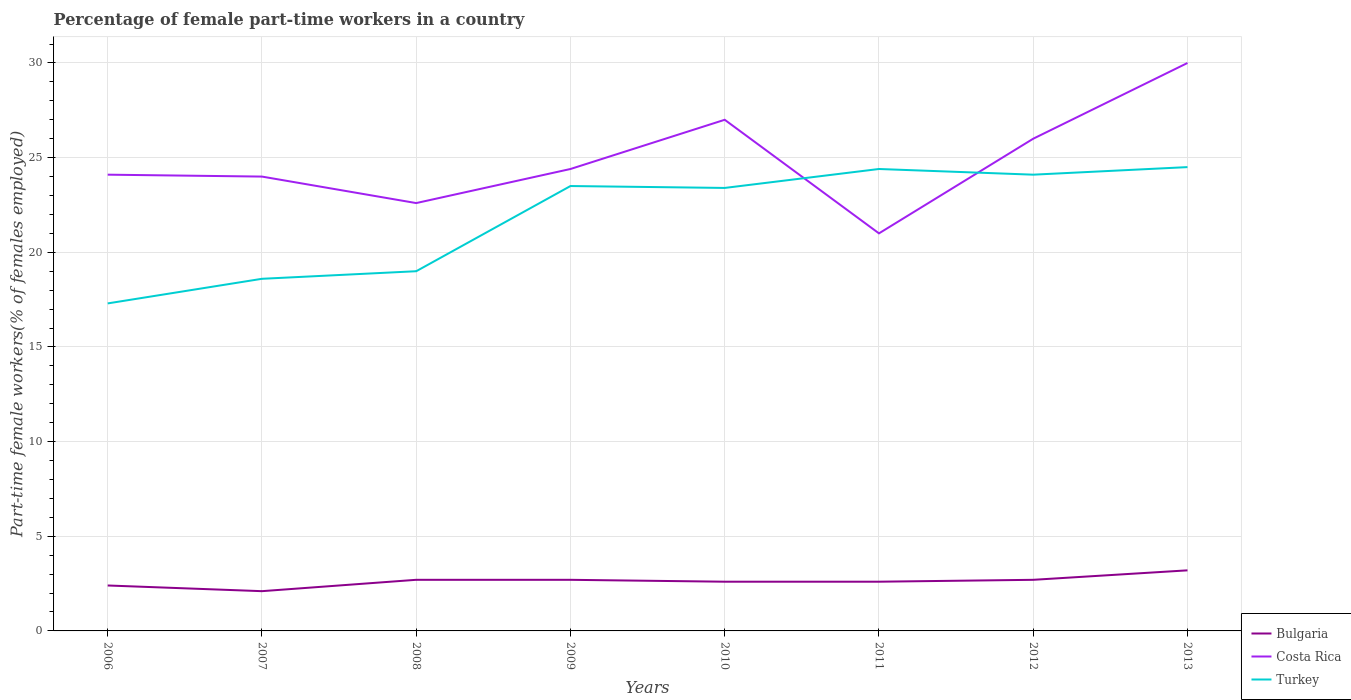Does the line corresponding to Costa Rica intersect with the line corresponding to Bulgaria?
Provide a short and direct response. No. Is the number of lines equal to the number of legend labels?
Ensure brevity in your answer.  Yes. Across all years, what is the maximum percentage of female part-time workers in Costa Rica?
Offer a terse response. 21. What is the total percentage of female part-time workers in Costa Rica in the graph?
Your answer should be very brief. -1.8. What is the difference between the highest and the second highest percentage of female part-time workers in Turkey?
Your answer should be compact. 7.2. What is the difference between the highest and the lowest percentage of female part-time workers in Turkey?
Your answer should be very brief. 5. Are the values on the major ticks of Y-axis written in scientific E-notation?
Make the answer very short. No. Does the graph contain grids?
Provide a short and direct response. Yes. Where does the legend appear in the graph?
Your answer should be very brief. Bottom right. How are the legend labels stacked?
Your answer should be very brief. Vertical. What is the title of the graph?
Ensure brevity in your answer.  Percentage of female part-time workers in a country. Does "Liberia" appear as one of the legend labels in the graph?
Your answer should be compact. No. What is the label or title of the X-axis?
Your answer should be very brief. Years. What is the label or title of the Y-axis?
Ensure brevity in your answer.  Part-time female workers(% of females employed). What is the Part-time female workers(% of females employed) of Bulgaria in 2006?
Keep it short and to the point. 2.4. What is the Part-time female workers(% of females employed) of Costa Rica in 2006?
Your response must be concise. 24.1. What is the Part-time female workers(% of females employed) in Turkey in 2006?
Provide a succinct answer. 17.3. What is the Part-time female workers(% of females employed) of Bulgaria in 2007?
Provide a short and direct response. 2.1. What is the Part-time female workers(% of females employed) in Costa Rica in 2007?
Your answer should be compact. 24. What is the Part-time female workers(% of females employed) in Turkey in 2007?
Give a very brief answer. 18.6. What is the Part-time female workers(% of females employed) of Bulgaria in 2008?
Your answer should be compact. 2.7. What is the Part-time female workers(% of females employed) in Costa Rica in 2008?
Ensure brevity in your answer.  22.6. What is the Part-time female workers(% of females employed) of Bulgaria in 2009?
Provide a short and direct response. 2.7. What is the Part-time female workers(% of females employed) of Costa Rica in 2009?
Make the answer very short. 24.4. What is the Part-time female workers(% of females employed) of Bulgaria in 2010?
Your answer should be compact. 2.6. What is the Part-time female workers(% of females employed) in Turkey in 2010?
Ensure brevity in your answer.  23.4. What is the Part-time female workers(% of females employed) of Bulgaria in 2011?
Provide a succinct answer. 2.6. What is the Part-time female workers(% of females employed) of Costa Rica in 2011?
Provide a short and direct response. 21. What is the Part-time female workers(% of females employed) of Turkey in 2011?
Keep it short and to the point. 24.4. What is the Part-time female workers(% of females employed) of Bulgaria in 2012?
Provide a short and direct response. 2.7. What is the Part-time female workers(% of females employed) of Costa Rica in 2012?
Provide a succinct answer. 26. What is the Part-time female workers(% of females employed) of Turkey in 2012?
Make the answer very short. 24.1. What is the Part-time female workers(% of females employed) in Bulgaria in 2013?
Keep it short and to the point. 3.2. What is the Part-time female workers(% of females employed) in Costa Rica in 2013?
Make the answer very short. 30. What is the Part-time female workers(% of females employed) of Turkey in 2013?
Ensure brevity in your answer.  24.5. Across all years, what is the maximum Part-time female workers(% of females employed) in Bulgaria?
Your answer should be very brief. 3.2. Across all years, what is the minimum Part-time female workers(% of females employed) in Bulgaria?
Give a very brief answer. 2.1. Across all years, what is the minimum Part-time female workers(% of females employed) in Costa Rica?
Offer a very short reply. 21. Across all years, what is the minimum Part-time female workers(% of females employed) of Turkey?
Your answer should be compact. 17.3. What is the total Part-time female workers(% of females employed) of Costa Rica in the graph?
Offer a very short reply. 199.1. What is the total Part-time female workers(% of females employed) in Turkey in the graph?
Provide a succinct answer. 174.8. What is the difference between the Part-time female workers(% of females employed) of Bulgaria in 2006 and that in 2007?
Make the answer very short. 0.3. What is the difference between the Part-time female workers(% of females employed) in Bulgaria in 2006 and that in 2008?
Offer a terse response. -0.3. What is the difference between the Part-time female workers(% of females employed) of Costa Rica in 2006 and that in 2008?
Offer a very short reply. 1.5. What is the difference between the Part-time female workers(% of females employed) in Turkey in 2006 and that in 2008?
Make the answer very short. -1.7. What is the difference between the Part-time female workers(% of females employed) in Bulgaria in 2006 and that in 2009?
Keep it short and to the point. -0.3. What is the difference between the Part-time female workers(% of females employed) of Costa Rica in 2006 and that in 2009?
Make the answer very short. -0.3. What is the difference between the Part-time female workers(% of females employed) in Bulgaria in 2006 and that in 2010?
Ensure brevity in your answer.  -0.2. What is the difference between the Part-time female workers(% of females employed) in Turkey in 2006 and that in 2010?
Offer a very short reply. -6.1. What is the difference between the Part-time female workers(% of females employed) of Costa Rica in 2006 and that in 2011?
Your response must be concise. 3.1. What is the difference between the Part-time female workers(% of females employed) of Turkey in 2006 and that in 2011?
Give a very brief answer. -7.1. What is the difference between the Part-time female workers(% of females employed) in Costa Rica in 2006 and that in 2013?
Offer a very short reply. -5.9. What is the difference between the Part-time female workers(% of females employed) of Bulgaria in 2007 and that in 2008?
Give a very brief answer. -0.6. What is the difference between the Part-time female workers(% of females employed) of Bulgaria in 2007 and that in 2010?
Your response must be concise. -0.5. What is the difference between the Part-time female workers(% of females employed) of Bulgaria in 2007 and that in 2011?
Ensure brevity in your answer.  -0.5. What is the difference between the Part-time female workers(% of females employed) of Bulgaria in 2007 and that in 2012?
Offer a terse response. -0.6. What is the difference between the Part-time female workers(% of females employed) in Costa Rica in 2007 and that in 2012?
Provide a short and direct response. -2. What is the difference between the Part-time female workers(% of females employed) in Costa Rica in 2007 and that in 2013?
Ensure brevity in your answer.  -6. What is the difference between the Part-time female workers(% of females employed) in Turkey in 2007 and that in 2013?
Ensure brevity in your answer.  -5.9. What is the difference between the Part-time female workers(% of females employed) of Costa Rica in 2008 and that in 2010?
Make the answer very short. -4.4. What is the difference between the Part-time female workers(% of females employed) in Turkey in 2008 and that in 2010?
Keep it short and to the point. -4.4. What is the difference between the Part-time female workers(% of females employed) of Bulgaria in 2008 and that in 2011?
Your response must be concise. 0.1. What is the difference between the Part-time female workers(% of females employed) of Costa Rica in 2008 and that in 2012?
Your answer should be very brief. -3.4. What is the difference between the Part-time female workers(% of females employed) in Bulgaria in 2008 and that in 2013?
Keep it short and to the point. -0.5. What is the difference between the Part-time female workers(% of females employed) in Costa Rica in 2008 and that in 2013?
Offer a very short reply. -7.4. What is the difference between the Part-time female workers(% of females employed) in Bulgaria in 2009 and that in 2010?
Ensure brevity in your answer.  0.1. What is the difference between the Part-time female workers(% of females employed) of Turkey in 2009 and that in 2010?
Offer a terse response. 0.1. What is the difference between the Part-time female workers(% of females employed) in Bulgaria in 2009 and that in 2011?
Ensure brevity in your answer.  0.1. What is the difference between the Part-time female workers(% of females employed) of Costa Rica in 2009 and that in 2012?
Ensure brevity in your answer.  -1.6. What is the difference between the Part-time female workers(% of females employed) of Bulgaria in 2009 and that in 2013?
Keep it short and to the point. -0.5. What is the difference between the Part-time female workers(% of females employed) in Costa Rica in 2009 and that in 2013?
Offer a very short reply. -5.6. What is the difference between the Part-time female workers(% of females employed) of Bulgaria in 2010 and that in 2011?
Make the answer very short. 0. What is the difference between the Part-time female workers(% of females employed) in Turkey in 2010 and that in 2011?
Your answer should be very brief. -1. What is the difference between the Part-time female workers(% of females employed) of Costa Rica in 2010 and that in 2012?
Offer a very short reply. 1. What is the difference between the Part-time female workers(% of females employed) of Turkey in 2010 and that in 2012?
Your response must be concise. -0.7. What is the difference between the Part-time female workers(% of females employed) in Bulgaria in 2010 and that in 2013?
Your answer should be very brief. -0.6. What is the difference between the Part-time female workers(% of females employed) in Costa Rica in 2010 and that in 2013?
Provide a succinct answer. -3. What is the difference between the Part-time female workers(% of females employed) in Bulgaria in 2011 and that in 2012?
Your response must be concise. -0.1. What is the difference between the Part-time female workers(% of females employed) of Costa Rica in 2011 and that in 2012?
Provide a succinct answer. -5. What is the difference between the Part-time female workers(% of females employed) in Turkey in 2011 and that in 2012?
Provide a short and direct response. 0.3. What is the difference between the Part-time female workers(% of females employed) in Bulgaria in 2011 and that in 2013?
Offer a very short reply. -0.6. What is the difference between the Part-time female workers(% of females employed) in Costa Rica in 2012 and that in 2013?
Your answer should be very brief. -4. What is the difference between the Part-time female workers(% of females employed) of Bulgaria in 2006 and the Part-time female workers(% of females employed) of Costa Rica in 2007?
Provide a succinct answer. -21.6. What is the difference between the Part-time female workers(% of females employed) of Bulgaria in 2006 and the Part-time female workers(% of females employed) of Turkey in 2007?
Ensure brevity in your answer.  -16.2. What is the difference between the Part-time female workers(% of females employed) of Costa Rica in 2006 and the Part-time female workers(% of females employed) of Turkey in 2007?
Offer a very short reply. 5.5. What is the difference between the Part-time female workers(% of females employed) in Bulgaria in 2006 and the Part-time female workers(% of females employed) in Costa Rica in 2008?
Keep it short and to the point. -20.2. What is the difference between the Part-time female workers(% of females employed) in Bulgaria in 2006 and the Part-time female workers(% of females employed) in Turkey in 2008?
Offer a very short reply. -16.6. What is the difference between the Part-time female workers(% of females employed) in Costa Rica in 2006 and the Part-time female workers(% of females employed) in Turkey in 2008?
Make the answer very short. 5.1. What is the difference between the Part-time female workers(% of females employed) of Bulgaria in 2006 and the Part-time female workers(% of females employed) of Turkey in 2009?
Your response must be concise. -21.1. What is the difference between the Part-time female workers(% of females employed) in Costa Rica in 2006 and the Part-time female workers(% of females employed) in Turkey in 2009?
Provide a succinct answer. 0.6. What is the difference between the Part-time female workers(% of females employed) of Bulgaria in 2006 and the Part-time female workers(% of females employed) of Costa Rica in 2010?
Offer a very short reply. -24.6. What is the difference between the Part-time female workers(% of females employed) of Bulgaria in 2006 and the Part-time female workers(% of females employed) of Turkey in 2010?
Keep it short and to the point. -21. What is the difference between the Part-time female workers(% of females employed) in Costa Rica in 2006 and the Part-time female workers(% of females employed) in Turkey in 2010?
Make the answer very short. 0.7. What is the difference between the Part-time female workers(% of females employed) in Bulgaria in 2006 and the Part-time female workers(% of females employed) in Costa Rica in 2011?
Provide a short and direct response. -18.6. What is the difference between the Part-time female workers(% of females employed) in Bulgaria in 2006 and the Part-time female workers(% of females employed) in Turkey in 2011?
Provide a succinct answer. -22. What is the difference between the Part-time female workers(% of females employed) in Costa Rica in 2006 and the Part-time female workers(% of females employed) in Turkey in 2011?
Provide a succinct answer. -0.3. What is the difference between the Part-time female workers(% of females employed) in Bulgaria in 2006 and the Part-time female workers(% of females employed) in Costa Rica in 2012?
Your response must be concise. -23.6. What is the difference between the Part-time female workers(% of females employed) in Bulgaria in 2006 and the Part-time female workers(% of females employed) in Turkey in 2012?
Your response must be concise. -21.7. What is the difference between the Part-time female workers(% of females employed) of Costa Rica in 2006 and the Part-time female workers(% of females employed) of Turkey in 2012?
Make the answer very short. 0. What is the difference between the Part-time female workers(% of females employed) of Bulgaria in 2006 and the Part-time female workers(% of females employed) of Costa Rica in 2013?
Provide a succinct answer. -27.6. What is the difference between the Part-time female workers(% of females employed) in Bulgaria in 2006 and the Part-time female workers(% of females employed) in Turkey in 2013?
Provide a short and direct response. -22.1. What is the difference between the Part-time female workers(% of females employed) of Bulgaria in 2007 and the Part-time female workers(% of females employed) of Costa Rica in 2008?
Offer a very short reply. -20.5. What is the difference between the Part-time female workers(% of females employed) in Bulgaria in 2007 and the Part-time female workers(% of females employed) in Turkey in 2008?
Your answer should be very brief. -16.9. What is the difference between the Part-time female workers(% of females employed) in Costa Rica in 2007 and the Part-time female workers(% of females employed) in Turkey in 2008?
Provide a succinct answer. 5. What is the difference between the Part-time female workers(% of females employed) in Bulgaria in 2007 and the Part-time female workers(% of females employed) in Costa Rica in 2009?
Provide a succinct answer. -22.3. What is the difference between the Part-time female workers(% of females employed) of Bulgaria in 2007 and the Part-time female workers(% of females employed) of Turkey in 2009?
Provide a succinct answer. -21.4. What is the difference between the Part-time female workers(% of females employed) of Costa Rica in 2007 and the Part-time female workers(% of females employed) of Turkey in 2009?
Give a very brief answer. 0.5. What is the difference between the Part-time female workers(% of females employed) of Bulgaria in 2007 and the Part-time female workers(% of females employed) of Costa Rica in 2010?
Offer a terse response. -24.9. What is the difference between the Part-time female workers(% of females employed) in Bulgaria in 2007 and the Part-time female workers(% of females employed) in Turkey in 2010?
Provide a succinct answer. -21.3. What is the difference between the Part-time female workers(% of females employed) in Bulgaria in 2007 and the Part-time female workers(% of females employed) in Costa Rica in 2011?
Your answer should be very brief. -18.9. What is the difference between the Part-time female workers(% of females employed) of Bulgaria in 2007 and the Part-time female workers(% of females employed) of Turkey in 2011?
Give a very brief answer. -22.3. What is the difference between the Part-time female workers(% of females employed) in Costa Rica in 2007 and the Part-time female workers(% of females employed) in Turkey in 2011?
Keep it short and to the point. -0.4. What is the difference between the Part-time female workers(% of females employed) in Bulgaria in 2007 and the Part-time female workers(% of females employed) in Costa Rica in 2012?
Your response must be concise. -23.9. What is the difference between the Part-time female workers(% of females employed) of Bulgaria in 2007 and the Part-time female workers(% of females employed) of Turkey in 2012?
Provide a succinct answer. -22. What is the difference between the Part-time female workers(% of females employed) of Costa Rica in 2007 and the Part-time female workers(% of females employed) of Turkey in 2012?
Keep it short and to the point. -0.1. What is the difference between the Part-time female workers(% of females employed) in Bulgaria in 2007 and the Part-time female workers(% of females employed) in Costa Rica in 2013?
Your response must be concise. -27.9. What is the difference between the Part-time female workers(% of females employed) in Bulgaria in 2007 and the Part-time female workers(% of females employed) in Turkey in 2013?
Keep it short and to the point. -22.4. What is the difference between the Part-time female workers(% of females employed) in Costa Rica in 2007 and the Part-time female workers(% of females employed) in Turkey in 2013?
Make the answer very short. -0.5. What is the difference between the Part-time female workers(% of females employed) of Bulgaria in 2008 and the Part-time female workers(% of females employed) of Costa Rica in 2009?
Offer a very short reply. -21.7. What is the difference between the Part-time female workers(% of females employed) in Bulgaria in 2008 and the Part-time female workers(% of females employed) in Turkey in 2009?
Provide a succinct answer. -20.8. What is the difference between the Part-time female workers(% of females employed) in Bulgaria in 2008 and the Part-time female workers(% of females employed) in Costa Rica in 2010?
Offer a very short reply. -24.3. What is the difference between the Part-time female workers(% of females employed) of Bulgaria in 2008 and the Part-time female workers(% of females employed) of Turkey in 2010?
Ensure brevity in your answer.  -20.7. What is the difference between the Part-time female workers(% of females employed) in Bulgaria in 2008 and the Part-time female workers(% of females employed) in Costa Rica in 2011?
Your response must be concise. -18.3. What is the difference between the Part-time female workers(% of females employed) in Bulgaria in 2008 and the Part-time female workers(% of females employed) in Turkey in 2011?
Provide a succinct answer. -21.7. What is the difference between the Part-time female workers(% of females employed) of Bulgaria in 2008 and the Part-time female workers(% of females employed) of Costa Rica in 2012?
Give a very brief answer. -23.3. What is the difference between the Part-time female workers(% of females employed) of Bulgaria in 2008 and the Part-time female workers(% of females employed) of Turkey in 2012?
Give a very brief answer. -21.4. What is the difference between the Part-time female workers(% of females employed) of Costa Rica in 2008 and the Part-time female workers(% of females employed) of Turkey in 2012?
Give a very brief answer. -1.5. What is the difference between the Part-time female workers(% of females employed) of Bulgaria in 2008 and the Part-time female workers(% of females employed) of Costa Rica in 2013?
Offer a very short reply. -27.3. What is the difference between the Part-time female workers(% of females employed) of Bulgaria in 2008 and the Part-time female workers(% of females employed) of Turkey in 2013?
Offer a terse response. -21.8. What is the difference between the Part-time female workers(% of females employed) in Costa Rica in 2008 and the Part-time female workers(% of females employed) in Turkey in 2013?
Make the answer very short. -1.9. What is the difference between the Part-time female workers(% of females employed) of Bulgaria in 2009 and the Part-time female workers(% of females employed) of Costa Rica in 2010?
Provide a short and direct response. -24.3. What is the difference between the Part-time female workers(% of females employed) of Bulgaria in 2009 and the Part-time female workers(% of females employed) of Turkey in 2010?
Offer a terse response. -20.7. What is the difference between the Part-time female workers(% of females employed) in Bulgaria in 2009 and the Part-time female workers(% of females employed) in Costa Rica in 2011?
Ensure brevity in your answer.  -18.3. What is the difference between the Part-time female workers(% of females employed) of Bulgaria in 2009 and the Part-time female workers(% of females employed) of Turkey in 2011?
Give a very brief answer. -21.7. What is the difference between the Part-time female workers(% of females employed) of Costa Rica in 2009 and the Part-time female workers(% of females employed) of Turkey in 2011?
Your answer should be very brief. 0. What is the difference between the Part-time female workers(% of females employed) of Bulgaria in 2009 and the Part-time female workers(% of females employed) of Costa Rica in 2012?
Your answer should be very brief. -23.3. What is the difference between the Part-time female workers(% of females employed) of Bulgaria in 2009 and the Part-time female workers(% of females employed) of Turkey in 2012?
Ensure brevity in your answer.  -21.4. What is the difference between the Part-time female workers(% of females employed) of Bulgaria in 2009 and the Part-time female workers(% of females employed) of Costa Rica in 2013?
Ensure brevity in your answer.  -27.3. What is the difference between the Part-time female workers(% of females employed) of Bulgaria in 2009 and the Part-time female workers(% of females employed) of Turkey in 2013?
Your answer should be very brief. -21.8. What is the difference between the Part-time female workers(% of females employed) of Costa Rica in 2009 and the Part-time female workers(% of females employed) of Turkey in 2013?
Keep it short and to the point. -0.1. What is the difference between the Part-time female workers(% of females employed) in Bulgaria in 2010 and the Part-time female workers(% of females employed) in Costa Rica in 2011?
Offer a very short reply. -18.4. What is the difference between the Part-time female workers(% of females employed) in Bulgaria in 2010 and the Part-time female workers(% of females employed) in Turkey in 2011?
Your answer should be compact. -21.8. What is the difference between the Part-time female workers(% of females employed) in Bulgaria in 2010 and the Part-time female workers(% of females employed) in Costa Rica in 2012?
Keep it short and to the point. -23.4. What is the difference between the Part-time female workers(% of females employed) of Bulgaria in 2010 and the Part-time female workers(% of females employed) of Turkey in 2012?
Ensure brevity in your answer.  -21.5. What is the difference between the Part-time female workers(% of females employed) of Costa Rica in 2010 and the Part-time female workers(% of females employed) of Turkey in 2012?
Offer a very short reply. 2.9. What is the difference between the Part-time female workers(% of females employed) in Bulgaria in 2010 and the Part-time female workers(% of females employed) in Costa Rica in 2013?
Your answer should be compact. -27.4. What is the difference between the Part-time female workers(% of females employed) in Bulgaria in 2010 and the Part-time female workers(% of females employed) in Turkey in 2013?
Your answer should be very brief. -21.9. What is the difference between the Part-time female workers(% of females employed) in Bulgaria in 2011 and the Part-time female workers(% of females employed) in Costa Rica in 2012?
Offer a terse response. -23.4. What is the difference between the Part-time female workers(% of females employed) of Bulgaria in 2011 and the Part-time female workers(% of females employed) of Turkey in 2012?
Your response must be concise. -21.5. What is the difference between the Part-time female workers(% of females employed) of Bulgaria in 2011 and the Part-time female workers(% of females employed) of Costa Rica in 2013?
Keep it short and to the point. -27.4. What is the difference between the Part-time female workers(% of females employed) of Bulgaria in 2011 and the Part-time female workers(% of females employed) of Turkey in 2013?
Offer a terse response. -21.9. What is the difference between the Part-time female workers(% of females employed) in Costa Rica in 2011 and the Part-time female workers(% of females employed) in Turkey in 2013?
Make the answer very short. -3.5. What is the difference between the Part-time female workers(% of females employed) of Bulgaria in 2012 and the Part-time female workers(% of females employed) of Costa Rica in 2013?
Provide a succinct answer. -27.3. What is the difference between the Part-time female workers(% of females employed) of Bulgaria in 2012 and the Part-time female workers(% of females employed) of Turkey in 2013?
Your response must be concise. -21.8. What is the average Part-time female workers(% of females employed) of Bulgaria per year?
Keep it short and to the point. 2.62. What is the average Part-time female workers(% of females employed) in Costa Rica per year?
Your response must be concise. 24.89. What is the average Part-time female workers(% of females employed) of Turkey per year?
Give a very brief answer. 21.85. In the year 2006, what is the difference between the Part-time female workers(% of females employed) of Bulgaria and Part-time female workers(% of females employed) of Costa Rica?
Offer a very short reply. -21.7. In the year 2006, what is the difference between the Part-time female workers(% of females employed) in Bulgaria and Part-time female workers(% of females employed) in Turkey?
Keep it short and to the point. -14.9. In the year 2006, what is the difference between the Part-time female workers(% of females employed) of Costa Rica and Part-time female workers(% of females employed) of Turkey?
Your response must be concise. 6.8. In the year 2007, what is the difference between the Part-time female workers(% of females employed) of Bulgaria and Part-time female workers(% of females employed) of Costa Rica?
Offer a very short reply. -21.9. In the year 2007, what is the difference between the Part-time female workers(% of females employed) in Bulgaria and Part-time female workers(% of females employed) in Turkey?
Make the answer very short. -16.5. In the year 2008, what is the difference between the Part-time female workers(% of females employed) in Bulgaria and Part-time female workers(% of females employed) in Costa Rica?
Your answer should be compact. -19.9. In the year 2008, what is the difference between the Part-time female workers(% of females employed) in Bulgaria and Part-time female workers(% of females employed) in Turkey?
Keep it short and to the point. -16.3. In the year 2008, what is the difference between the Part-time female workers(% of females employed) in Costa Rica and Part-time female workers(% of females employed) in Turkey?
Provide a short and direct response. 3.6. In the year 2009, what is the difference between the Part-time female workers(% of females employed) of Bulgaria and Part-time female workers(% of females employed) of Costa Rica?
Your response must be concise. -21.7. In the year 2009, what is the difference between the Part-time female workers(% of females employed) in Bulgaria and Part-time female workers(% of females employed) in Turkey?
Keep it short and to the point. -20.8. In the year 2009, what is the difference between the Part-time female workers(% of females employed) of Costa Rica and Part-time female workers(% of females employed) of Turkey?
Provide a succinct answer. 0.9. In the year 2010, what is the difference between the Part-time female workers(% of females employed) in Bulgaria and Part-time female workers(% of females employed) in Costa Rica?
Keep it short and to the point. -24.4. In the year 2010, what is the difference between the Part-time female workers(% of females employed) of Bulgaria and Part-time female workers(% of females employed) of Turkey?
Make the answer very short. -20.8. In the year 2011, what is the difference between the Part-time female workers(% of females employed) of Bulgaria and Part-time female workers(% of females employed) of Costa Rica?
Offer a very short reply. -18.4. In the year 2011, what is the difference between the Part-time female workers(% of females employed) of Bulgaria and Part-time female workers(% of females employed) of Turkey?
Offer a very short reply. -21.8. In the year 2012, what is the difference between the Part-time female workers(% of females employed) in Bulgaria and Part-time female workers(% of females employed) in Costa Rica?
Give a very brief answer. -23.3. In the year 2012, what is the difference between the Part-time female workers(% of females employed) in Bulgaria and Part-time female workers(% of females employed) in Turkey?
Provide a short and direct response. -21.4. In the year 2012, what is the difference between the Part-time female workers(% of females employed) of Costa Rica and Part-time female workers(% of females employed) of Turkey?
Offer a very short reply. 1.9. In the year 2013, what is the difference between the Part-time female workers(% of females employed) of Bulgaria and Part-time female workers(% of females employed) of Costa Rica?
Your response must be concise. -26.8. In the year 2013, what is the difference between the Part-time female workers(% of females employed) of Bulgaria and Part-time female workers(% of females employed) of Turkey?
Your response must be concise. -21.3. In the year 2013, what is the difference between the Part-time female workers(% of females employed) of Costa Rica and Part-time female workers(% of females employed) of Turkey?
Offer a very short reply. 5.5. What is the ratio of the Part-time female workers(% of females employed) of Bulgaria in 2006 to that in 2007?
Offer a very short reply. 1.14. What is the ratio of the Part-time female workers(% of females employed) of Turkey in 2006 to that in 2007?
Your answer should be very brief. 0.93. What is the ratio of the Part-time female workers(% of females employed) of Bulgaria in 2006 to that in 2008?
Your response must be concise. 0.89. What is the ratio of the Part-time female workers(% of females employed) in Costa Rica in 2006 to that in 2008?
Make the answer very short. 1.07. What is the ratio of the Part-time female workers(% of females employed) of Turkey in 2006 to that in 2008?
Your response must be concise. 0.91. What is the ratio of the Part-time female workers(% of females employed) of Turkey in 2006 to that in 2009?
Ensure brevity in your answer.  0.74. What is the ratio of the Part-time female workers(% of females employed) of Bulgaria in 2006 to that in 2010?
Your response must be concise. 0.92. What is the ratio of the Part-time female workers(% of females employed) in Costa Rica in 2006 to that in 2010?
Keep it short and to the point. 0.89. What is the ratio of the Part-time female workers(% of females employed) in Turkey in 2006 to that in 2010?
Provide a succinct answer. 0.74. What is the ratio of the Part-time female workers(% of females employed) in Costa Rica in 2006 to that in 2011?
Ensure brevity in your answer.  1.15. What is the ratio of the Part-time female workers(% of females employed) in Turkey in 2006 to that in 2011?
Offer a terse response. 0.71. What is the ratio of the Part-time female workers(% of females employed) in Costa Rica in 2006 to that in 2012?
Provide a short and direct response. 0.93. What is the ratio of the Part-time female workers(% of females employed) in Turkey in 2006 to that in 2012?
Your answer should be compact. 0.72. What is the ratio of the Part-time female workers(% of females employed) of Bulgaria in 2006 to that in 2013?
Provide a short and direct response. 0.75. What is the ratio of the Part-time female workers(% of females employed) in Costa Rica in 2006 to that in 2013?
Make the answer very short. 0.8. What is the ratio of the Part-time female workers(% of females employed) in Turkey in 2006 to that in 2013?
Your answer should be very brief. 0.71. What is the ratio of the Part-time female workers(% of females employed) of Costa Rica in 2007 to that in 2008?
Make the answer very short. 1.06. What is the ratio of the Part-time female workers(% of females employed) in Turkey in 2007 to that in 2008?
Your answer should be compact. 0.98. What is the ratio of the Part-time female workers(% of females employed) of Bulgaria in 2007 to that in 2009?
Give a very brief answer. 0.78. What is the ratio of the Part-time female workers(% of females employed) of Costa Rica in 2007 to that in 2009?
Offer a very short reply. 0.98. What is the ratio of the Part-time female workers(% of females employed) of Turkey in 2007 to that in 2009?
Keep it short and to the point. 0.79. What is the ratio of the Part-time female workers(% of females employed) of Bulgaria in 2007 to that in 2010?
Give a very brief answer. 0.81. What is the ratio of the Part-time female workers(% of females employed) of Turkey in 2007 to that in 2010?
Your response must be concise. 0.79. What is the ratio of the Part-time female workers(% of females employed) in Bulgaria in 2007 to that in 2011?
Make the answer very short. 0.81. What is the ratio of the Part-time female workers(% of females employed) in Costa Rica in 2007 to that in 2011?
Give a very brief answer. 1.14. What is the ratio of the Part-time female workers(% of females employed) of Turkey in 2007 to that in 2011?
Offer a terse response. 0.76. What is the ratio of the Part-time female workers(% of females employed) in Turkey in 2007 to that in 2012?
Provide a short and direct response. 0.77. What is the ratio of the Part-time female workers(% of females employed) of Bulgaria in 2007 to that in 2013?
Make the answer very short. 0.66. What is the ratio of the Part-time female workers(% of females employed) of Costa Rica in 2007 to that in 2013?
Your response must be concise. 0.8. What is the ratio of the Part-time female workers(% of females employed) in Turkey in 2007 to that in 2013?
Offer a very short reply. 0.76. What is the ratio of the Part-time female workers(% of females employed) in Bulgaria in 2008 to that in 2009?
Provide a short and direct response. 1. What is the ratio of the Part-time female workers(% of females employed) in Costa Rica in 2008 to that in 2009?
Provide a short and direct response. 0.93. What is the ratio of the Part-time female workers(% of females employed) in Turkey in 2008 to that in 2009?
Provide a succinct answer. 0.81. What is the ratio of the Part-time female workers(% of females employed) of Costa Rica in 2008 to that in 2010?
Provide a succinct answer. 0.84. What is the ratio of the Part-time female workers(% of females employed) of Turkey in 2008 to that in 2010?
Your response must be concise. 0.81. What is the ratio of the Part-time female workers(% of females employed) in Bulgaria in 2008 to that in 2011?
Provide a succinct answer. 1.04. What is the ratio of the Part-time female workers(% of females employed) of Costa Rica in 2008 to that in 2011?
Your answer should be very brief. 1.08. What is the ratio of the Part-time female workers(% of females employed) in Turkey in 2008 to that in 2011?
Your response must be concise. 0.78. What is the ratio of the Part-time female workers(% of females employed) of Bulgaria in 2008 to that in 2012?
Make the answer very short. 1. What is the ratio of the Part-time female workers(% of females employed) of Costa Rica in 2008 to that in 2012?
Provide a short and direct response. 0.87. What is the ratio of the Part-time female workers(% of females employed) of Turkey in 2008 to that in 2012?
Offer a terse response. 0.79. What is the ratio of the Part-time female workers(% of females employed) of Bulgaria in 2008 to that in 2013?
Your answer should be compact. 0.84. What is the ratio of the Part-time female workers(% of females employed) in Costa Rica in 2008 to that in 2013?
Provide a succinct answer. 0.75. What is the ratio of the Part-time female workers(% of females employed) of Turkey in 2008 to that in 2013?
Give a very brief answer. 0.78. What is the ratio of the Part-time female workers(% of females employed) of Bulgaria in 2009 to that in 2010?
Offer a very short reply. 1.04. What is the ratio of the Part-time female workers(% of females employed) in Costa Rica in 2009 to that in 2010?
Your answer should be compact. 0.9. What is the ratio of the Part-time female workers(% of females employed) in Turkey in 2009 to that in 2010?
Your response must be concise. 1. What is the ratio of the Part-time female workers(% of females employed) in Bulgaria in 2009 to that in 2011?
Provide a succinct answer. 1.04. What is the ratio of the Part-time female workers(% of females employed) of Costa Rica in 2009 to that in 2011?
Make the answer very short. 1.16. What is the ratio of the Part-time female workers(% of females employed) of Turkey in 2009 to that in 2011?
Your response must be concise. 0.96. What is the ratio of the Part-time female workers(% of females employed) of Bulgaria in 2009 to that in 2012?
Keep it short and to the point. 1. What is the ratio of the Part-time female workers(% of females employed) in Costa Rica in 2009 to that in 2012?
Keep it short and to the point. 0.94. What is the ratio of the Part-time female workers(% of females employed) in Turkey in 2009 to that in 2012?
Offer a very short reply. 0.98. What is the ratio of the Part-time female workers(% of females employed) of Bulgaria in 2009 to that in 2013?
Your response must be concise. 0.84. What is the ratio of the Part-time female workers(% of females employed) of Costa Rica in 2009 to that in 2013?
Your answer should be compact. 0.81. What is the ratio of the Part-time female workers(% of females employed) in Turkey in 2009 to that in 2013?
Your answer should be compact. 0.96. What is the ratio of the Part-time female workers(% of females employed) in Costa Rica in 2010 to that in 2011?
Offer a terse response. 1.29. What is the ratio of the Part-time female workers(% of females employed) in Turkey in 2010 to that in 2011?
Keep it short and to the point. 0.96. What is the ratio of the Part-time female workers(% of females employed) in Turkey in 2010 to that in 2012?
Give a very brief answer. 0.97. What is the ratio of the Part-time female workers(% of females employed) of Bulgaria in 2010 to that in 2013?
Your answer should be compact. 0.81. What is the ratio of the Part-time female workers(% of females employed) in Turkey in 2010 to that in 2013?
Your answer should be very brief. 0.96. What is the ratio of the Part-time female workers(% of females employed) of Bulgaria in 2011 to that in 2012?
Ensure brevity in your answer.  0.96. What is the ratio of the Part-time female workers(% of females employed) of Costa Rica in 2011 to that in 2012?
Ensure brevity in your answer.  0.81. What is the ratio of the Part-time female workers(% of females employed) of Turkey in 2011 to that in 2012?
Make the answer very short. 1.01. What is the ratio of the Part-time female workers(% of females employed) of Bulgaria in 2011 to that in 2013?
Your answer should be very brief. 0.81. What is the ratio of the Part-time female workers(% of females employed) of Costa Rica in 2011 to that in 2013?
Make the answer very short. 0.7. What is the ratio of the Part-time female workers(% of females employed) of Bulgaria in 2012 to that in 2013?
Give a very brief answer. 0.84. What is the ratio of the Part-time female workers(% of females employed) in Costa Rica in 2012 to that in 2013?
Offer a terse response. 0.87. What is the ratio of the Part-time female workers(% of females employed) in Turkey in 2012 to that in 2013?
Ensure brevity in your answer.  0.98. What is the difference between the highest and the lowest Part-time female workers(% of females employed) of Turkey?
Provide a succinct answer. 7.2. 